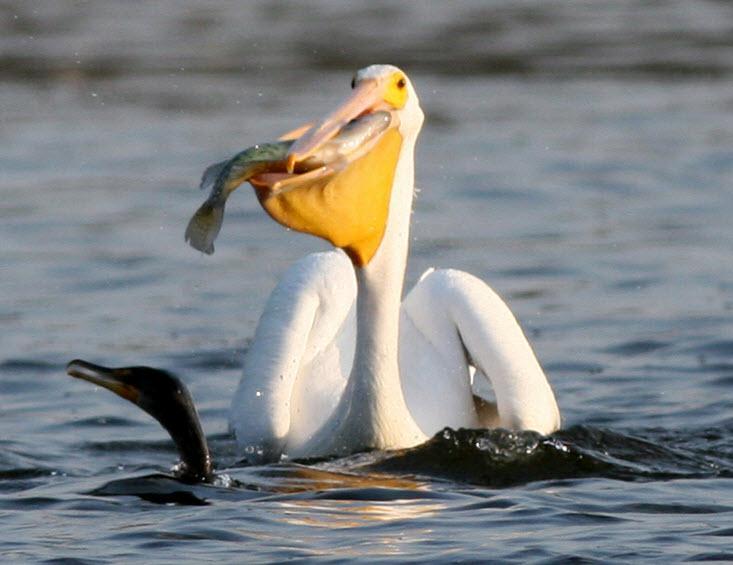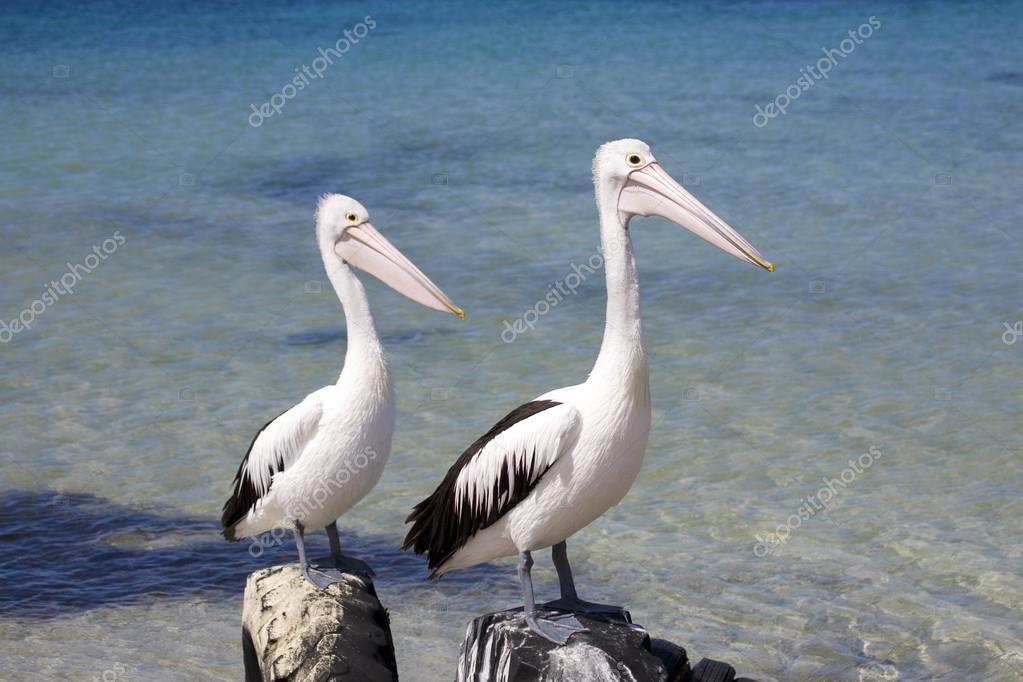The first image is the image on the left, the second image is the image on the right. For the images displayed, is the sentence "In one of the image two birds are on a log facing left." factually correct? Answer yes or no. No. The first image is the image on the left, the second image is the image on the right. For the images shown, is this caption "One of the pelicans has a fish in its mouth." true? Answer yes or no. Yes. 